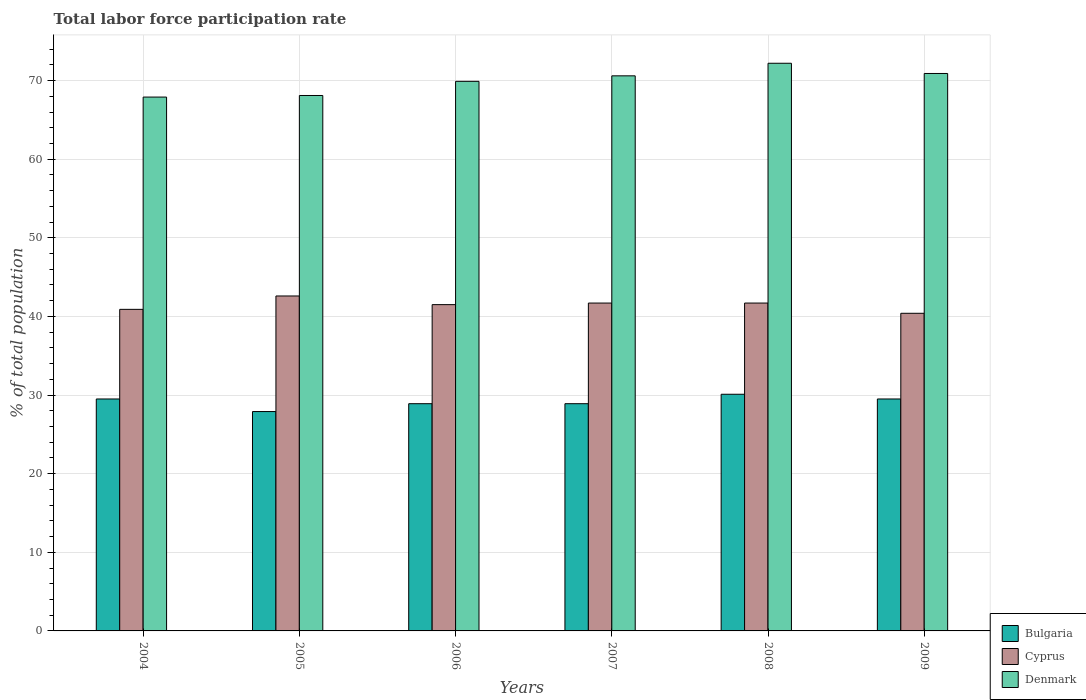How many groups of bars are there?
Your response must be concise. 6. Are the number of bars on each tick of the X-axis equal?
Give a very brief answer. Yes. How many bars are there on the 5th tick from the left?
Make the answer very short. 3. What is the label of the 4th group of bars from the left?
Your answer should be compact. 2007. What is the total labor force participation rate in Bulgaria in 2005?
Your answer should be very brief. 27.9. Across all years, what is the maximum total labor force participation rate in Denmark?
Make the answer very short. 72.2. Across all years, what is the minimum total labor force participation rate in Cyprus?
Offer a very short reply. 40.4. What is the total total labor force participation rate in Denmark in the graph?
Offer a terse response. 419.6. What is the difference between the total labor force participation rate in Cyprus in 2004 and that in 2005?
Ensure brevity in your answer.  -1.7. What is the difference between the total labor force participation rate in Bulgaria in 2007 and the total labor force participation rate in Cyprus in 2009?
Provide a short and direct response. -11.5. What is the average total labor force participation rate in Cyprus per year?
Ensure brevity in your answer.  41.47. In the year 2006, what is the difference between the total labor force participation rate in Denmark and total labor force participation rate in Cyprus?
Ensure brevity in your answer.  28.4. In how many years, is the total labor force participation rate in Bulgaria greater than 62 %?
Ensure brevity in your answer.  0. What is the ratio of the total labor force participation rate in Cyprus in 2006 to that in 2007?
Offer a terse response. 1. Is the total labor force participation rate in Denmark in 2006 less than that in 2008?
Make the answer very short. Yes. What is the difference between the highest and the second highest total labor force participation rate in Bulgaria?
Your answer should be very brief. 0.6. What is the difference between the highest and the lowest total labor force participation rate in Denmark?
Ensure brevity in your answer.  4.3. Is the sum of the total labor force participation rate in Bulgaria in 2005 and 2006 greater than the maximum total labor force participation rate in Denmark across all years?
Offer a very short reply. No. What does the 2nd bar from the right in 2007 represents?
Provide a succinct answer. Cyprus. Is it the case that in every year, the sum of the total labor force participation rate in Denmark and total labor force participation rate in Cyprus is greater than the total labor force participation rate in Bulgaria?
Offer a very short reply. Yes. Are all the bars in the graph horizontal?
Make the answer very short. No. How many years are there in the graph?
Your response must be concise. 6. Does the graph contain any zero values?
Provide a short and direct response. No. How are the legend labels stacked?
Provide a succinct answer. Vertical. What is the title of the graph?
Provide a succinct answer. Total labor force participation rate. What is the label or title of the Y-axis?
Give a very brief answer. % of total population. What is the % of total population of Bulgaria in 2004?
Ensure brevity in your answer.  29.5. What is the % of total population of Cyprus in 2004?
Provide a succinct answer. 40.9. What is the % of total population in Denmark in 2004?
Give a very brief answer. 67.9. What is the % of total population in Bulgaria in 2005?
Make the answer very short. 27.9. What is the % of total population in Cyprus in 2005?
Provide a short and direct response. 42.6. What is the % of total population of Denmark in 2005?
Make the answer very short. 68.1. What is the % of total population of Bulgaria in 2006?
Offer a very short reply. 28.9. What is the % of total population of Cyprus in 2006?
Offer a terse response. 41.5. What is the % of total population of Denmark in 2006?
Ensure brevity in your answer.  69.9. What is the % of total population of Bulgaria in 2007?
Your answer should be compact. 28.9. What is the % of total population of Cyprus in 2007?
Your response must be concise. 41.7. What is the % of total population of Denmark in 2007?
Ensure brevity in your answer.  70.6. What is the % of total population in Bulgaria in 2008?
Offer a very short reply. 30.1. What is the % of total population of Cyprus in 2008?
Your response must be concise. 41.7. What is the % of total population of Denmark in 2008?
Your answer should be very brief. 72.2. What is the % of total population in Bulgaria in 2009?
Give a very brief answer. 29.5. What is the % of total population in Cyprus in 2009?
Provide a short and direct response. 40.4. What is the % of total population of Denmark in 2009?
Make the answer very short. 70.9. Across all years, what is the maximum % of total population in Bulgaria?
Offer a terse response. 30.1. Across all years, what is the maximum % of total population in Cyprus?
Give a very brief answer. 42.6. Across all years, what is the maximum % of total population in Denmark?
Your answer should be very brief. 72.2. Across all years, what is the minimum % of total population in Bulgaria?
Make the answer very short. 27.9. Across all years, what is the minimum % of total population in Cyprus?
Make the answer very short. 40.4. Across all years, what is the minimum % of total population of Denmark?
Offer a very short reply. 67.9. What is the total % of total population of Bulgaria in the graph?
Your response must be concise. 174.8. What is the total % of total population in Cyprus in the graph?
Keep it short and to the point. 248.8. What is the total % of total population in Denmark in the graph?
Offer a very short reply. 419.6. What is the difference between the % of total population of Denmark in 2004 and that in 2005?
Provide a succinct answer. -0.2. What is the difference between the % of total population of Denmark in 2004 and that in 2006?
Keep it short and to the point. -2. What is the difference between the % of total population of Bulgaria in 2004 and that in 2007?
Make the answer very short. 0.6. What is the difference between the % of total population in Cyprus in 2004 and that in 2007?
Ensure brevity in your answer.  -0.8. What is the difference between the % of total population in Bulgaria in 2004 and that in 2008?
Your answer should be compact. -0.6. What is the difference between the % of total population in Cyprus in 2004 and that in 2008?
Your answer should be very brief. -0.8. What is the difference between the % of total population of Denmark in 2004 and that in 2008?
Offer a terse response. -4.3. What is the difference between the % of total population of Bulgaria in 2005 and that in 2006?
Provide a succinct answer. -1. What is the difference between the % of total population of Cyprus in 2005 and that in 2006?
Provide a succinct answer. 1.1. What is the difference between the % of total population of Cyprus in 2005 and that in 2007?
Offer a terse response. 0.9. What is the difference between the % of total population of Bulgaria in 2005 and that in 2008?
Your answer should be compact. -2.2. What is the difference between the % of total population of Bulgaria in 2005 and that in 2009?
Your answer should be very brief. -1.6. What is the difference between the % of total population in Denmark in 2005 and that in 2009?
Give a very brief answer. -2.8. What is the difference between the % of total population of Cyprus in 2006 and that in 2007?
Provide a succinct answer. -0.2. What is the difference between the % of total population of Denmark in 2006 and that in 2007?
Your response must be concise. -0.7. What is the difference between the % of total population of Bulgaria in 2006 and that in 2008?
Your answer should be compact. -1.2. What is the difference between the % of total population in Cyprus in 2006 and that in 2008?
Offer a very short reply. -0.2. What is the difference between the % of total population in Denmark in 2006 and that in 2008?
Keep it short and to the point. -2.3. What is the difference between the % of total population of Cyprus in 2006 and that in 2009?
Ensure brevity in your answer.  1.1. What is the difference between the % of total population of Bulgaria in 2007 and that in 2008?
Keep it short and to the point. -1.2. What is the difference between the % of total population of Bulgaria in 2007 and that in 2009?
Provide a short and direct response. -0.6. What is the difference between the % of total population in Bulgaria in 2008 and that in 2009?
Your answer should be compact. 0.6. What is the difference between the % of total population of Denmark in 2008 and that in 2009?
Give a very brief answer. 1.3. What is the difference between the % of total population of Bulgaria in 2004 and the % of total population of Denmark in 2005?
Your response must be concise. -38.6. What is the difference between the % of total population of Cyprus in 2004 and the % of total population of Denmark in 2005?
Make the answer very short. -27.2. What is the difference between the % of total population of Bulgaria in 2004 and the % of total population of Cyprus in 2006?
Your answer should be compact. -12. What is the difference between the % of total population in Bulgaria in 2004 and the % of total population in Denmark in 2006?
Ensure brevity in your answer.  -40.4. What is the difference between the % of total population of Cyprus in 2004 and the % of total population of Denmark in 2006?
Provide a short and direct response. -29. What is the difference between the % of total population of Bulgaria in 2004 and the % of total population of Denmark in 2007?
Give a very brief answer. -41.1. What is the difference between the % of total population of Cyprus in 2004 and the % of total population of Denmark in 2007?
Provide a short and direct response. -29.7. What is the difference between the % of total population of Bulgaria in 2004 and the % of total population of Denmark in 2008?
Your response must be concise. -42.7. What is the difference between the % of total population of Cyprus in 2004 and the % of total population of Denmark in 2008?
Ensure brevity in your answer.  -31.3. What is the difference between the % of total population of Bulgaria in 2004 and the % of total population of Denmark in 2009?
Ensure brevity in your answer.  -41.4. What is the difference between the % of total population in Bulgaria in 2005 and the % of total population in Cyprus in 2006?
Your answer should be compact. -13.6. What is the difference between the % of total population of Bulgaria in 2005 and the % of total population of Denmark in 2006?
Give a very brief answer. -42. What is the difference between the % of total population of Cyprus in 2005 and the % of total population of Denmark in 2006?
Your answer should be compact. -27.3. What is the difference between the % of total population of Bulgaria in 2005 and the % of total population of Cyprus in 2007?
Make the answer very short. -13.8. What is the difference between the % of total population of Bulgaria in 2005 and the % of total population of Denmark in 2007?
Provide a succinct answer. -42.7. What is the difference between the % of total population in Bulgaria in 2005 and the % of total population in Cyprus in 2008?
Your response must be concise. -13.8. What is the difference between the % of total population of Bulgaria in 2005 and the % of total population of Denmark in 2008?
Your answer should be compact. -44.3. What is the difference between the % of total population in Cyprus in 2005 and the % of total population in Denmark in 2008?
Provide a succinct answer. -29.6. What is the difference between the % of total population of Bulgaria in 2005 and the % of total population of Cyprus in 2009?
Your answer should be compact. -12.5. What is the difference between the % of total population of Bulgaria in 2005 and the % of total population of Denmark in 2009?
Your answer should be very brief. -43. What is the difference between the % of total population of Cyprus in 2005 and the % of total population of Denmark in 2009?
Keep it short and to the point. -28.3. What is the difference between the % of total population of Bulgaria in 2006 and the % of total population of Cyprus in 2007?
Ensure brevity in your answer.  -12.8. What is the difference between the % of total population of Bulgaria in 2006 and the % of total population of Denmark in 2007?
Provide a succinct answer. -41.7. What is the difference between the % of total population of Cyprus in 2006 and the % of total population of Denmark in 2007?
Make the answer very short. -29.1. What is the difference between the % of total population of Bulgaria in 2006 and the % of total population of Cyprus in 2008?
Give a very brief answer. -12.8. What is the difference between the % of total population of Bulgaria in 2006 and the % of total population of Denmark in 2008?
Keep it short and to the point. -43.3. What is the difference between the % of total population of Cyprus in 2006 and the % of total population of Denmark in 2008?
Your answer should be very brief. -30.7. What is the difference between the % of total population in Bulgaria in 2006 and the % of total population in Denmark in 2009?
Make the answer very short. -42. What is the difference between the % of total population of Cyprus in 2006 and the % of total population of Denmark in 2009?
Keep it short and to the point. -29.4. What is the difference between the % of total population in Bulgaria in 2007 and the % of total population in Cyprus in 2008?
Your response must be concise. -12.8. What is the difference between the % of total population of Bulgaria in 2007 and the % of total population of Denmark in 2008?
Ensure brevity in your answer.  -43.3. What is the difference between the % of total population in Cyprus in 2007 and the % of total population in Denmark in 2008?
Make the answer very short. -30.5. What is the difference between the % of total population in Bulgaria in 2007 and the % of total population in Cyprus in 2009?
Provide a succinct answer. -11.5. What is the difference between the % of total population in Bulgaria in 2007 and the % of total population in Denmark in 2009?
Provide a succinct answer. -42. What is the difference between the % of total population of Cyprus in 2007 and the % of total population of Denmark in 2009?
Your answer should be compact. -29.2. What is the difference between the % of total population of Bulgaria in 2008 and the % of total population of Denmark in 2009?
Offer a terse response. -40.8. What is the difference between the % of total population in Cyprus in 2008 and the % of total population in Denmark in 2009?
Provide a short and direct response. -29.2. What is the average % of total population in Bulgaria per year?
Provide a succinct answer. 29.13. What is the average % of total population in Cyprus per year?
Your response must be concise. 41.47. What is the average % of total population in Denmark per year?
Provide a short and direct response. 69.93. In the year 2004, what is the difference between the % of total population of Bulgaria and % of total population of Cyprus?
Give a very brief answer. -11.4. In the year 2004, what is the difference between the % of total population in Bulgaria and % of total population in Denmark?
Offer a terse response. -38.4. In the year 2004, what is the difference between the % of total population in Cyprus and % of total population in Denmark?
Offer a very short reply. -27. In the year 2005, what is the difference between the % of total population of Bulgaria and % of total population of Cyprus?
Provide a succinct answer. -14.7. In the year 2005, what is the difference between the % of total population in Bulgaria and % of total population in Denmark?
Make the answer very short. -40.2. In the year 2005, what is the difference between the % of total population in Cyprus and % of total population in Denmark?
Ensure brevity in your answer.  -25.5. In the year 2006, what is the difference between the % of total population of Bulgaria and % of total population of Cyprus?
Your answer should be compact. -12.6. In the year 2006, what is the difference between the % of total population of Bulgaria and % of total population of Denmark?
Offer a very short reply. -41. In the year 2006, what is the difference between the % of total population of Cyprus and % of total population of Denmark?
Ensure brevity in your answer.  -28.4. In the year 2007, what is the difference between the % of total population in Bulgaria and % of total population in Cyprus?
Make the answer very short. -12.8. In the year 2007, what is the difference between the % of total population of Bulgaria and % of total population of Denmark?
Provide a short and direct response. -41.7. In the year 2007, what is the difference between the % of total population in Cyprus and % of total population in Denmark?
Your response must be concise. -28.9. In the year 2008, what is the difference between the % of total population in Bulgaria and % of total population in Denmark?
Keep it short and to the point. -42.1. In the year 2008, what is the difference between the % of total population in Cyprus and % of total population in Denmark?
Your answer should be compact. -30.5. In the year 2009, what is the difference between the % of total population in Bulgaria and % of total population in Denmark?
Ensure brevity in your answer.  -41.4. In the year 2009, what is the difference between the % of total population in Cyprus and % of total population in Denmark?
Offer a very short reply. -30.5. What is the ratio of the % of total population of Bulgaria in 2004 to that in 2005?
Your answer should be very brief. 1.06. What is the ratio of the % of total population of Cyprus in 2004 to that in 2005?
Offer a terse response. 0.96. What is the ratio of the % of total population of Bulgaria in 2004 to that in 2006?
Give a very brief answer. 1.02. What is the ratio of the % of total population of Cyprus in 2004 to that in 2006?
Offer a very short reply. 0.99. What is the ratio of the % of total population of Denmark in 2004 to that in 2006?
Your answer should be very brief. 0.97. What is the ratio of the % of total population of Bulgaria in 2004 to that in 2007?
Your answer should be very brief. 1.02. What is the ratio of the % of total population of Cyprus in 2004 to that in 2007?
Your answer should be compact. 0.98. What is the ratio of the % of total population in Denmark in 2004 to that in 2007?
Your answer should be compact. 0.96. What is the ratio of the % of total population of Bulgaria in 2004 to that in 2008?
Make the answer very short. 0.98. What is the ratio of the % of total population of Cyprus in 2004 to that in 2008?
Offer a terse response. 0.98. What is the ratio of the % of total population in Denmark in 2004 to that in 2008?
Offer a terse response. 0.94. What is the ratio of the % of total population of Cyprus in 2004 to that in 2009?
Ensure brevity in your answer.  1.01. What is the ratio of the % of total population in Denmark in 2004 to that in 2009?
Make the answer very short. 0.96. What is the ratio of the % of total population in Bulgaria in 2005 to that in 2006?
Offer a very short reply. 0.97. What is the ratio of the % of total population in Cyprus in 2005 to that in 2006?
Ensure brevity in your answer.  1.03. What is the ratio of the % of total population in Denmark in 2005 to that in 2006?
Your answer should be very brief. 0.97. What is the ratio of the % of total population of Bulgaria in 2005 to that in 2007?
Your answer should be compact. 0.97. What is the ratio of the % of total population in Cyprus in 2005 to that in 2007?
Your answer should be very brief. 1.02. What is the ratio of the % of total population of Denmark in 2005 to that in 2007?
Offer a very short reply. 0.96. What is the ratio of the % of total population of Bulgaria in 2005 to that in 2008?
Your response must be concise. 0.93. What is the ratio of the % of total population in Cyprus in 2005 to that in 2008?
Ensure brevity in your answer.  1.02. What is the ratio of the % of total population of Denmark in 2005 to that in 2008?
Your answer should be compact. 0.94. What is the ratio of the % of total population in Bulgaria in 2005 to that in 2009?
Keep it short and to the point. 0.95. What is the ratio of the % of total population in Cyprus in 2005 to that in 2009?
Make the answer very short. 1.05. What is the ratio of the % of total population of Denmark in 2005 to that in 2009?
Keep it short and to the point. 0.96. What is the ratio of the % of total population in Cyprus in 2006 to that in 2007?
Make the answer very short. 1. What is the ratio of the % of total population in Bulgaria in 2006 to that in 2008?
Make the answer very short. 0.96. What is the ratio of the % of total population in Cyprus in 2006 to that in 2008?
Provide a succinct answer. 1. What is the ratio of the % of total population in Denmark in 2006 to that in 2008?
Your response must be concise. 0.97. What is the ratio of the % of total population in Bulgaria in 2006 to that in 2009?
Ensure brevity in your answer.  0.98. What is the ratio of the % of total population in Cyprus in 2006 to that in 2009?
Offer a terse response. 1.03. What is the ratio of the % of total population in Denmark in 2006 to that in 2009?
Your answer should be compact. 0.99. What is the ratio of the % of total population of Bulgaria in 2007 to that in 2008?
Keep it short and to the point. 0.96. What is the ratio of the % of total population of Denmark in 2007 to that in 2008?
Offer a terse response. 0.98. What is the ratio of the % of total population of Bulgaria in 2007 to that in 2009?
Your answer should be compact. 0.98. What is the ratio of the % of total population of Cyprus in 2007 to that in 2009?
Your answer should be very brief. 1.03. What is the ratio of the % of total population in Bulgaria in 2008 to that in 2009?
Offer a very short reply. 1.02. What is the ratio of the % of total population of Cyprus in 2008 to that in 2009?
Your answer should be compact. 1.03. What is the ratio of the % of total population of Denmark in 2008 to that in 2009?
Your answer should be compact. 1.02. What is the difference between the highest and the second highest % of total population of Denmark?
Your response must be concise. 1.3. What is the difference between the highest and the lowest % of total population of Bulgaria?
Give a very brief answer. 2.2. 